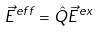Convert formula to latex. <formula><loc_0><loc_0><loc_500><loc_500>\vec { E } ^ { e f f } = \hat { Q } \vec { E } ^ { e x }</formula> 